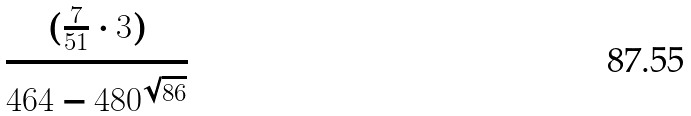Convert formula to latex. <formula><loc_0><loc_0><loc_500><loc_500>\frac { ( \frac { 7 } { 5 1 } \cdot 3 ) } { 4 6 4 - 4 8 0 ^ { \sqrt { 8 6 } } }</formula> 